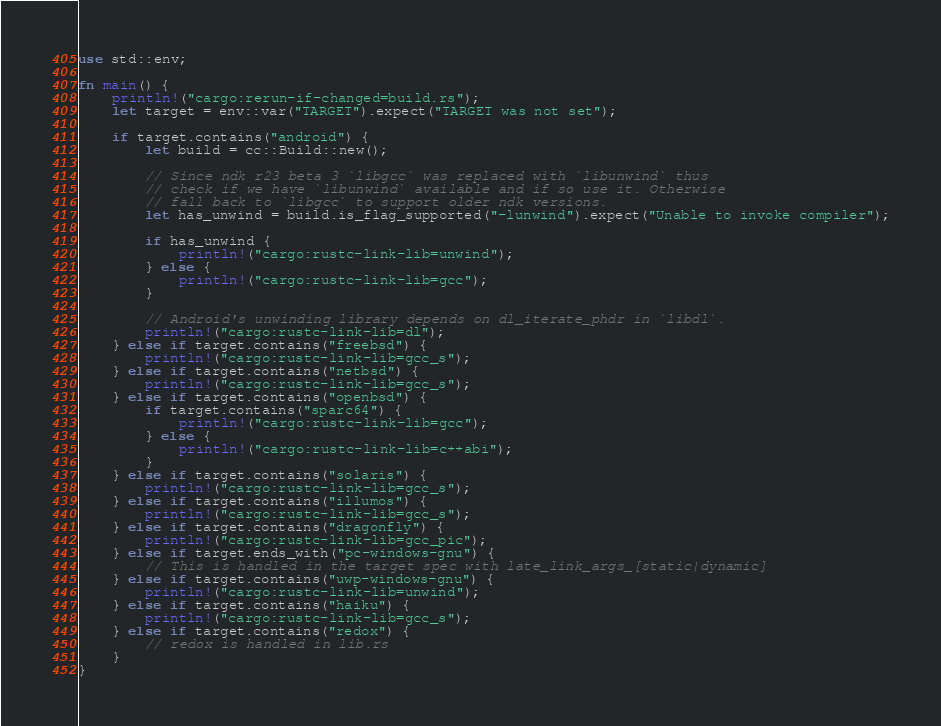<code> <loc_0><loc_0><loc_500><loc_500><_Rust_>use std::env;

fn main() {
    println!("cargo:rerun-if-changed=build.rs");
    let target = env::var("TARGET").expect("TARGET was not set");

    if target.contains("android") {
        let build = cc::Build::new();

        // Since ndk r23 beta 3 `libgcc` was replaced with `libunwind` thus
        // check if we have `libunwind` available and if so use it. Otherwise
        // fall back to `libgcc` to support older ndk versions.
        let has_unwind = build.is_flag_supported("-lunwind").expect("Unable to invoke compiler");

        if has_unwind {
            println!("cargo:rustc-link-lib=unwind");
        } else {
            println!("cargo:rustc-link-lib=gcc");
        }

        // Android's unwinding library depends on dl_iterate_phdr in `libdl`.
        println!("cargo:rustc-link-lib=dl");
    } else if target.contains("freebsd") {
        println!("cargo:rustc-link-lib=gcc_s");
    } else if target.contains("netbsd") {
        println!("cargo:rustc-link-lib=gcc_s");
    } else if target.contains("openbsd") {
        if target.contains("sparc64") {
            println!("cargo:rustc-link-lib=gcc");
        } else {
            println!("cargo:rustc-link-lib=c++abi");
        }
    } else if target.contains("solaris") {
        println!("cargo:rustc-link-lib=gcc_s");
    } else if target.contains("illumos") {
        println!("cargo:rustc-link-lib=gcc_s");
    } else if target.contains("dragonfly") {
        println!("cargo:rustc-link-lib=gcc_pic");
    } else if target.ends_with("pc-windows-gnu") {
        // This is handled in the target spec with late_link_args_[static|dynamic]
    } else if target.contains("uwp-windows-gnu") {
        println!("cargo:rustc-link-lib=unwind");
    } else if target.contains("haiku") {
        println!("cargo:rustc-link-lib=gcc_s");
    } else if target.contains("redox") {
        // redox is handled in lib.rs
    }
}
</code> 